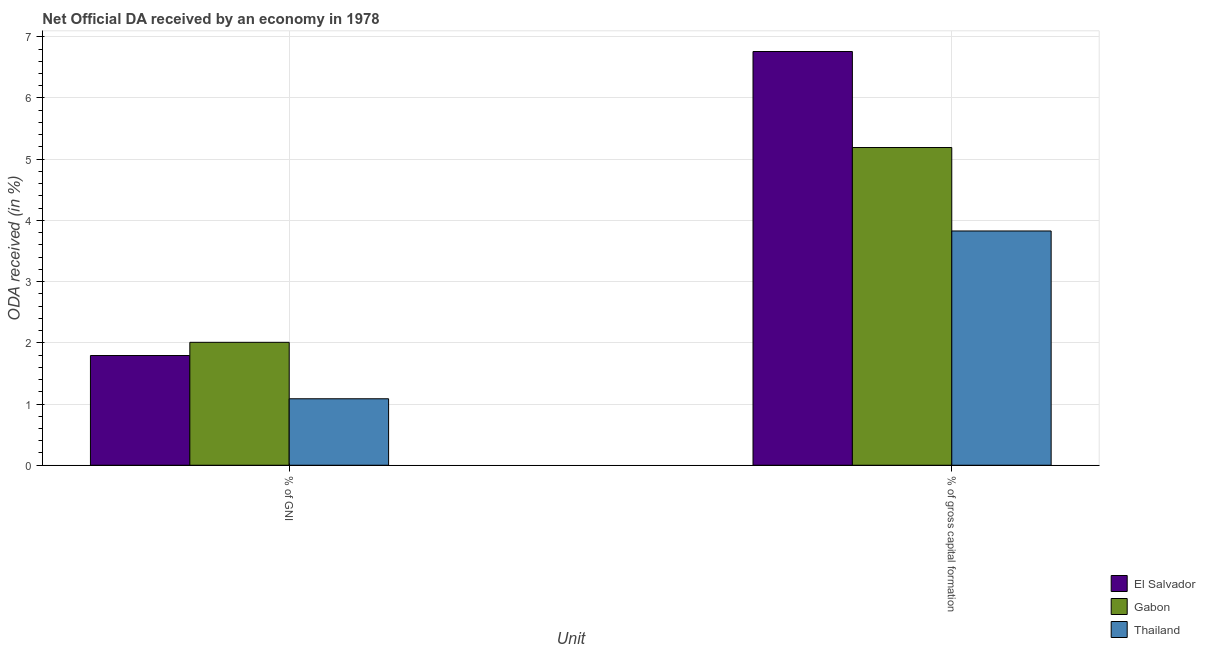How many groups of bars are there?
Give a very brief answer. 2. What is the label of the 1st group of bars from the left?
Your answer should be compact. % of GNI. What is the oda received as percentage of gni in Thailand?
Your response must be concise. 1.09. Across all countries, what is the maximum oda received as percentage of gross capital formation?
Ensure brevity in your answer.  6.76. Across all countries, what is the minimum oda received as percentage of gross capital formation?
Your answer should be very brief. 3.83. In which country was the oda received as percentage of gross capital formation maximum?
Offer a very short reply. El Salvador. In which country was the oda received as percentage of gross capital formation minimum?
Your answer should be very brief. Thailand. What is the total oda received as percentage of gni in the graph?
Your answer should be very brief. 4.89. What is the difference between the oda received as percentage of gross capital formation in El Salvador and that in Thailand?
Your answer should be very brief. 2.93. What is the difference between the oda received as percentage of gross capital formation in Thailand and the oda received as percentage of gni in El Salvador?
Offer a very short reply. 2.03. What is the average oda received as percentage of gni per country?
Your answer should be very brief. 1.63. What is the difference between the oda received as percentage of gross capital formation and oda received as percentage of gni in El Salvador?
Provide a short and direct response. 4.97. What is the ratio of the oda received as percentage of gross capital formation in Gabon to that in El Salvador?
Your answer should be compact. 0.77. What does the 3rd bar from the left in % of GNI represents?
Provide a succinct answer. Thailand. What does the 1st bar from the right in % of GNI represents?
Offer a terse response. Thailand. How many bars are there?
Ensure brevity in your answer.  6. What is the difference between two consecutive major ticks on the Y-axis?
Give a very brief answer. 1. Does the graph contain any zero values?
Ensure brevity in your answer.  No. Does the graph contain grids?
Give a very brief answer. Yes. What is the title of the graph?
Keep it short and to the point. Net Official DA received by an economy in 1978. Does "Heavily indebted poor countries" appear as one of the legend labels in the graph?
Your answer should be very brief. No. What is the label or title of the X-axis?
Give a very brief answer. Unit. What is the label or title of the Y-axis?
Keep it short and to the point. ODA received (in %). What is the ODA received (in %) of El Salvador in % of GNI?
Your response must be concise. 1.79. What is the ODA received (in %) in Gabon in % of GNI?
Keep it short and to the point. 2.01. What is the ODA received (in %) of Thailand in % of GNI?
Your answer should be very brief. 1.09. What is the ODA received (in %) in El Salvador in % of gross capital formation?
Provide a succinct answer. 6.76. What is the ODA received (in %) in Gabon in % of gross capital formation?
Your answer should be compact. 5.19. What is the ODA received (in %) in Thailand in % of gross capital formation?
Keep it short and to the point. 3.83. Across all Unit, what is the maximum ODA received (in %) in El Salvador?
Give a very brief answer. 6.76. Across all Unit, what is the maximum ODA received (in %) of Gabon?
Keep it short and to the point. 5.19. Across all Unit, what is the maximum ODA received (in %) of Thailand?
Provide a short and direct response. 3.83. Across all Unit, what is the minimum ODA received (in %) in El Salvador?
Your answer should be very brief. 1.79. Across all Unit, what is the minimum ODA received (in %) in Gabon?
Your response must be concise. 2.01. Across all Unit, what is the minimum ODA received (in %) in Thailand?
Ensure brevity in your answer.  1.09. What is the total ODA received (in %) of El Salvador in the graph?
Your answer should be compact. 8.55. What is the total ODA received (in %) of Gabon in the graph?
Ensure brevity in your answer.  7.2. What is the total ODA received (in %) in Thailand in the graph?
Provide a short and direct response. 4.91. What is the difference between the ODA received (in %) of El Salvador in % of GNI and that in % of gross capital formation?
Ensure brevity in your answer.  -4.97. What is the difference between the ODA received (in %) of Gabon in % of GNI and that in % of gross capital formation?
Ensure brevity in your answer.  -3.18. What is the difference between the ODA received (in %) of Thailand in % of GNI and that in % of gross capital formation?
Provide a short and direct response. -2.74. What is the difference between the ODA received (in %) of El Salvador in % of GNI and the ODA received (in %) of Gabon in % of gross capital formation?
Your response must be concise. -3.4. What is the difference between the ODA received (in %) of El Salvador in % of GNI and the ODA received (in %) of Thailand in % of gross capital formation?
Your response must be concise. -2.04. What is the difference between the ODA received (in %) of Gabon in % of GNI and the ODA received (in %) of Thailand in % of gross capital formation?
Give a very brief answer. -1.82. What is the average ODA received (in %) of El Salvador per Unit?
Ensure brevity in your answer.  4.28. What is the average ODA received (in %) of Gabon per Unit?
Your response must be concise. 3.6. What is the average ODA received (in %) in Thailand per Unit?
Give a very brief answer. 2.46. What is the difference between the ODA received (in %) of El Salvador and ODA received (in %) of Gabon in % of GNI?
Provide a succinct answer. -0.22. What is the difference between the ODA received (in %) of El Salvador and ODA received (in %) of Thailand in % of GNI?
Your response must be concise. 0.71. What is the difference between the ODA received (in %) in Gabon and ODA received (in %) in Thailand in % of GNI?
Provide a succinct answer. 0.92. What is the difference between the ODA received (in %) of El Salvador and ODA received (in %) of Gabon in % of gross capital formation?
Offer a terse response. 1.57. What is the difference between the ODA received (in %) of El Salvador and ODA received (in %) of Thailand in % of gross capital formation?
Offer a very short reply. 2.93. What is the difference between the ODA received (in %) of Gabon and ODA received (in %) of Thailand in % of gross capital formation?
Ensure brevity in your answer.  1.36. What is the ratio of the ODA received (in %) in El Salvador in % of GNI to that in % of gross capital formation?
Ensure brevity in your answer.  0.27. What is the ratio of the ODA received (in %) of Gabon in % of GNI to that in % of gross capital formation?
Provide a short and direct response. 0.39. What is the ratio of the ODA received (in %) in Thailand in % of GNI to that in % of gross capital formation?
Your answer should be compact. 0.28. What is the difference between the highest and the second highest ODA received (in %) of El Salvador?
Ensure brevity in your answer.  4.97. What is the difference between the highest and the second highest ODA received (in %) in Gabon?
Your response must be concise. 3.18. What is the difference between the highest and the second highest ODA received (in %) in Thailand?
Provide a succinct answer. 2.74. What is the difference between the highest and the lowest ODA received (in %) in El Salvador?
Your answer should be very brief. 4.97. What is the difference between the highest and the lowest ODA received (in %) of Gabon?
Provide a succinct answer. 3.18. What is the difference between the highest and the lowest ODA received (in %) in Thailand?
Your answer should be very brief. 2.74. 